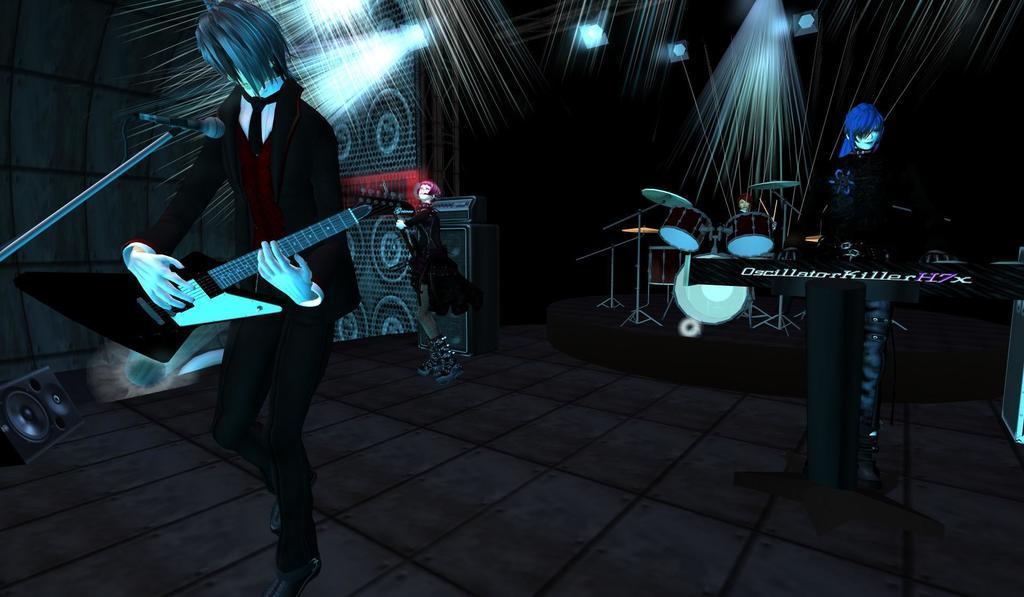How would you summarize this image in a sentence or two? In this image I can see an animated picture where I can see few cartoon characters are standing. In the front I can see one character is holding a guitar and in the front of him I can see a mic. In the background I can see few speakers, few lights and a drum set. 